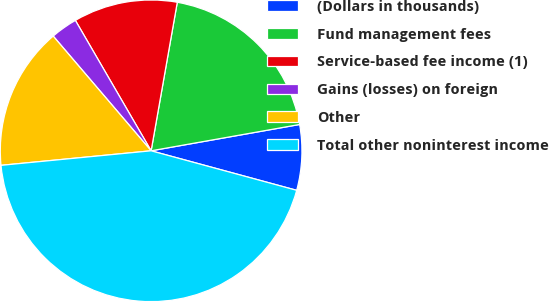Convert chart to OTSL. <chart><loc_0><loc_0><loc_500><loc_500><pie_chart><fcel>(Dollars in thousands)<fcel>Fund management fees<fcel>Service-based fee income (1)<fcel>Gains (losses) on foreign<fcel>Other<fcel>Total other noninterest income<nl><fcel>7.01%<fcel>19.43%<fcel>11.15%<fcel>2.87%<fcel>15.29%<fcel>44.24%<nl></chart> 